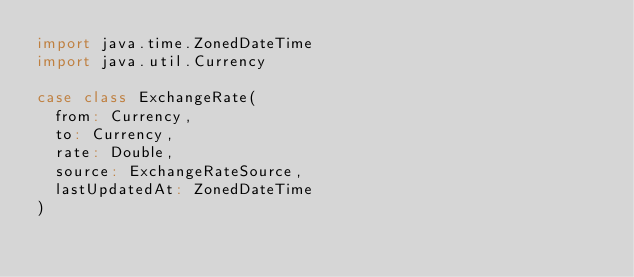Convert code to text. <code><loc_0><loc_0><loc_500><loc_500><_Scala_>import java.time.ZonedDateTime
import java.util.Currency

case class ExchangeRate(
  from: Currency,
  to: Currency,
  rate: Double,
  source: ExchangeRateSource,
  lastUpdatedAt: ZonedDateTime
)
</code> 